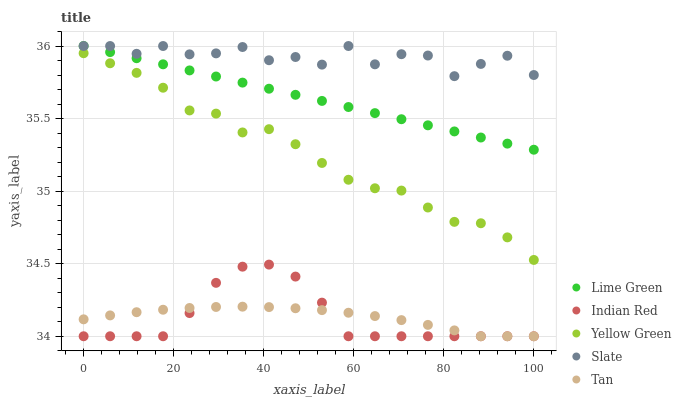Does Indian Red have the minimum area under the curve?
Answer yes or no. Yes. Does Slate have the maximum area under the curve?
Answer yes or no. Yes. Does Lime Green have the minimum area under the curve?
Answer yes or no. No. Does Lime Green have the maximum area under the curve?
Answer yes or no. No. Is Lime Green the smoothest?
Answer yes or no. Yes. Is Slate the roughest?
Answer yes or no. Yes. Is Slate the smoothest?
Answer yes or no. No. Is Lime Green the roughest?
Answer yes or no. No. Does Tan have the lowest value?
Answer yes or no. Yes. Does Lime Green have the lowest value?
Answer yes or no. No. Does Lime Green have the highest value?
Answer yes or no. Yes. Does Yellow Green have the highest value?
Answer yes or no. No. Is Tan less than Slate?
Answer yes or no. Yes. Is Lime Green greater than Yellow Green?
Answer yes or no. Yes. Does Slate intersect Lime Green?
Answer yes or no. Yes. Is Slate less than Lime Green?
Answer yes or no. No. Is Slate greater than Lime Green?
Answer yes or no. No. Does Tan intersect Slate?
Answer yes or no. No. 